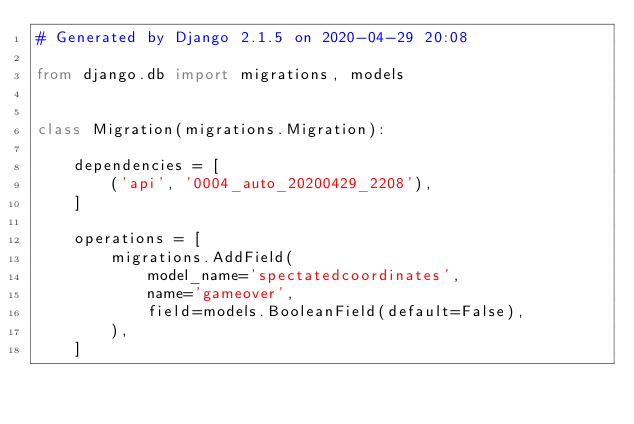<code> <loc_0><loc_0><loc_500><loc_500><_Python_># Generated by Django 2.1.5 on 2020-04-29 20:08

from django.db import migrations, models


class Migration(migrations.Migration):

    dependencies = [
        ('api', '0004_auto_20200429_2208'),
    ]

    operations = [
        migrations.AddField(
            model_name='spectatedcoordinates',
            name='gameover',
            field=models.BooleanField(default=False),
        ),
    ]
</code> 